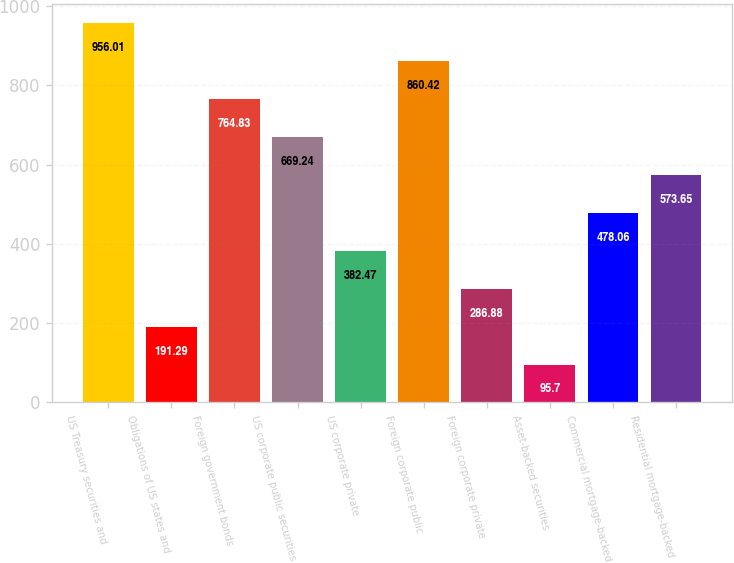Convert chart to OTSL. <chart><loc_0><loc_0><loc_500><loc_500><bar_chart><fcel>US Treasury securities and<fcel>Obligations of US states and<fcel>Foreign government bonds<fcel>US corporate public securities<fcel>US corporate private<fcel>Foreign corporate public<fcel>Foreign corporate private<fcel>Asset-backed securities<fcel>Commercial mortgage-backed<fcel>Residential mortgage-backed<nl><fcel>956.01<fcel>191.29<fcel>764.83<fcel>669.24<fcel>382.47<fcel>860.42<fcel>286.88<fcel>95.7<fcel>478.06<fcel>573.65<nl></chart> 